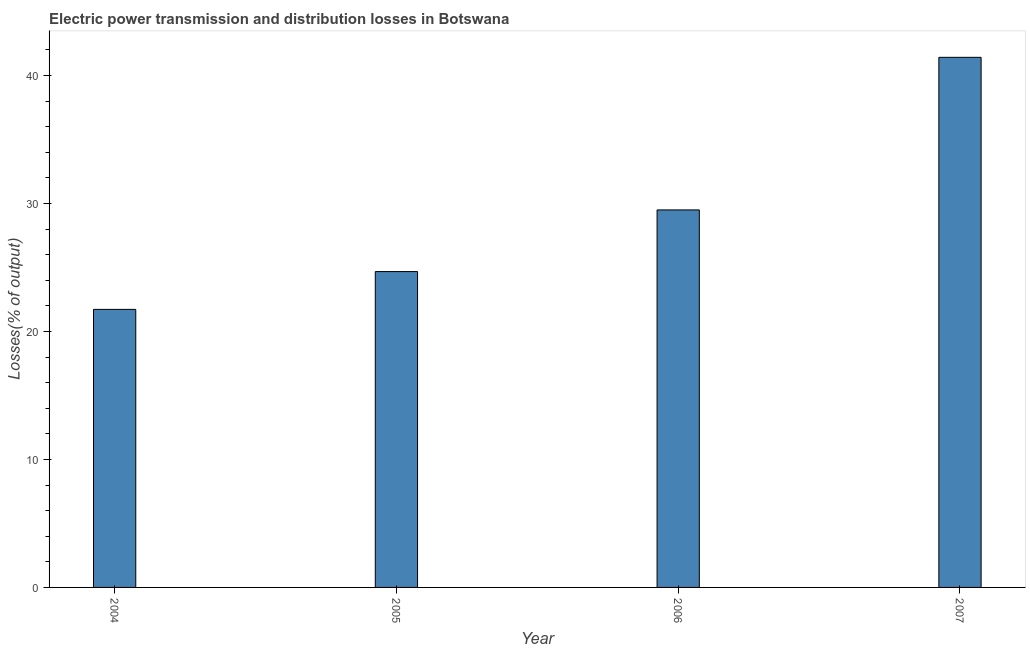Does the graph contain any zero values?
Your answer should be compact. No. Does the graph contain grids?
Offer a very short reply. No. What is the title of the graph?
Your answer should be very brief. Electric power transmission and distribution losses in Botswana. What is the label or title of the X-axis?
Make the answer very short. Year. What is the label or title of the Y-axis?
Provide a succinct answer. Losses(% of output). What is the electric power transmission and distribution losses in 2004?
Provide a succinct answer. 21.73. Across all years, what is the maximum electric power transmission and distribution losses?
Keep it short and to the point. 41.43. Across all years, what is the minimum electric power transmission and distribution losses?
Make the answer very short. 21.73. What is the sum of the electric power transmission and distribution losses?
Offer a terse response. 117.34. What is the difference between the electric power transmission and distribution losses in 2006 and 2007?
Keep it short and to the point. -11.92. What is the average electric power transmission and distribution losses per year?
Make the answer very short. 29.33. What is the median electric power transmission and distribution losses?
Your answer should be compact. 27.09. Do a majority of the years between 2006 and 2005 (inclusive) have electric power transmission and distribution losses greater than 26 %?
Offer a terse response. No. Is the electric power transmission and distribution losses in 2006 less than that in 2007?
Ensure brevity in your answer.  Yes. Is the difference between the electric power transmission and distribution losses in 2005 and 2006 greater than the difference between any two years?
Offer a terse response. No. What is the difference between the highest and the second highest electric power transmission and distribution losses?
Ensure brevity in your answer.  11.92. In how many years, is the electric power transmission and distribution losses greater than the average electric power transmission and distribution losses taken over all years?
Your answer should be very brief. 2. What is the Losses(% of output) in 2004?
Offer a terse response. 21.73. What is the Losses(% of output) in 2005?
Ensure brevity in your answer.  24.68. What is the Losses(% of output) of 2006?
Make the answer very short. 29.5. What is the Losses(% of output) of 2007?
Make the answer very short. 41.43. What is the difference between the Losses(% of output) in 2004 and 2005?
Your response must be concise. -2.95. What is the difference between the Losses(% of output) in 2004 and 2006?
Your answer should be compact. -7.77. What is the difference between the Losses(% of output) in 2004 and 2007?
Keep it short and to the point. -19.7. What is the difference between the Losses(% of output) in 2005 and 2006?
Your answer should be compact. -4.82. What is the difference between the Losses(% of output) in 2005 and 2007?
Your answer should be compact. -16.74. What is the difference between the Losses(% of output) in 2006 and 2007?
Ensure brevity in your answer.  -11.92. What is the ratio of the Losses(% of output) in 2004 to that in 2006?
Offer a very short reply. 0.74. What is the ratio of the Losses(% of output) in 2004 to that in 2007?
Your answer should be compact. 0.53. What is the ratio of the Losses(% of output) in 2005 to that in 2006?
Your answer should be very brief. 0.84. What is the ratio of the Losses(% of output) in 2005 to that in 2007?
Provide a short and direct response. 0.6. What is the ratio of the Losses(% of output) in 2006 to that in 2007?
Provide a succinct answer. 0.71. 